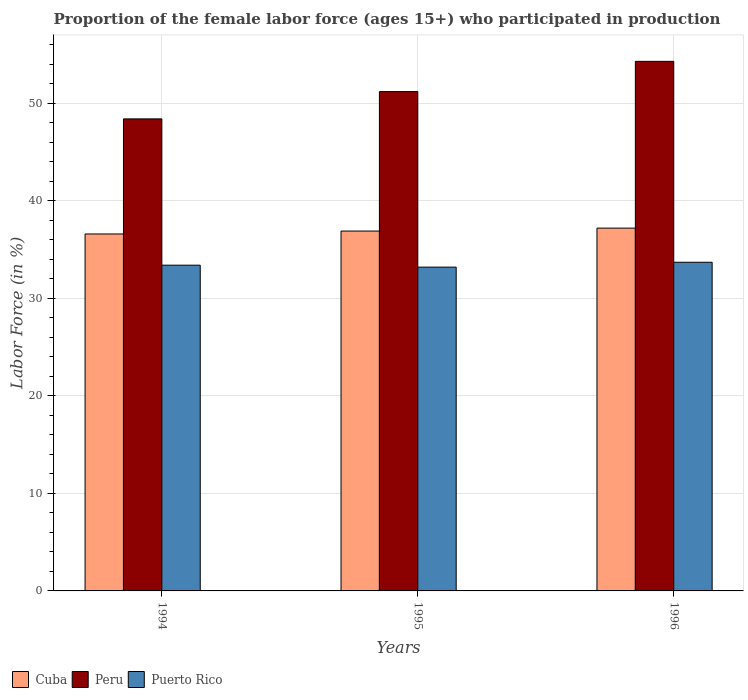How many different coloured bars are there?
Provide a short and direct response. 3. How many groups of bars are there?
Make the answer very short. 3. Are the number of bars per tick equal to the number of legend labels?
Your answer should be very brief. Yes. What is the label of the 1st group of bars from the left?
Keep it short and to the point. 1994. What is the proportion of the female labor force who participated in production in Peru in 1995?
Ensure brevity in your answer.  51.2. Across all years, what is the maximum proportion of the female labor force who participated in production in Puerto Rico?
Your response must be concise. 33.7. Across all years, what is the minimum proportion of the female labor force who participated in production in Peru?
Your answer should be very brief. 48.4. In which year was the proportion of the female labor force who participated in production in Peru minimum?
Provide a succinct answer. 1994. What is the total proportion of the female labor force who participated in production in Puerto Rico in the graph?
Offer a very short reply. 100.3. What is the difference between the proportion of the female labor force who participated in production in Cuba in 1995 and that in 1996?
Provide a short and direct response. -0.3. What is the difference between the proportion of the female labor force who participated in production in Peru in 1994 and the proportion of the female labor force who participated in production in Puerto Rico in 1995?
Ensure brevity in your answer.  15.2. What is the average proportion of the female labor force who participated in production in Puerto Rico per year?
Offer a very short reply. 33.43. In how many years, is the proportion of the female labor force who participated in production in Peru greater than 34 %?
Ensure brevity in your answer.  3. What is the ratio of the proportion of the female labor force who participated in production in Puerto Rico in 1994 to that in 1996?
Give a very brief answer. 0.99. What is the difference between the highest and the second highest proportion of the female labor force who participated in production in Cuba?
Make the answer very short. 0.3. In how many years, is the proportion of the female labor force who participated in production in Cuba greater than the average proportion of the female labor force who participated in production in Cuba taken over all years?
Your response must be concise. 2. Is the sum of the proportion of the female labor force who participated in production in Cuba in 1994 and 1996 greater than the maximum proportion of the female labor force who participated in production in Peru across all years?
Provide a short and direct response. Yes. What does the 1st bar from the right in 1995 represents?
Provide a short and direct response. Puerto Rico. How many bars are there?
Give a very brief answer. 9. How many years are there in the graph?
Offer a very short reply. 3. Does the graph contain any zero values?
Your answer should be compact. No. Does the graph contain grids?
Your answer should be compact. Yes. Where does the legend appear in the graph?
Your response must be concise. Bottom left. How are the legend labels stacked?
Give a very brief answer. Horizontal. What is the title of the graph?
Give a very brief answer. Proportion of the female labor force (ages 15+) who participated in production. What is the label or title of the X-axis?
Your answer should be compact. Years. What is the label or title of the Y-axis?
Ensure brevity in your answer.  Labor Force (in %). What is the Labor Force (in %) in Cuba in 1994?
Provide a succinct answer. 36.6. What is the Labor Force (in %) in Peru in 1994?
Your answer should be very brief. 48.4. What is the Labor Force (in %) of Puerto Rico in 1994?
Offer a terse response. 33.4. What is the Labor Force (in %) of Cuba in 1995?
Your answer should be compact. 36.9. What is the Labor Force (in %) in Peru in 1995?
Give a very brief answer. 51.2. What is the Labor Force (in %) of Puerto Rico in 1995?
Offer a very short reply. 33.2. What is the Labor Force (in %) in Cuba in 1996?
Make the answer very short. 37.2. What is the Labor Force (in %) of Peru in 1996?
Ensure brevity in your answer.  54.3. What is the Labor Force (in %) in Puerto Rico in 1996?
Provide a short and direct response. 33.7. Across all years, what is the maximum Labor Force (in %) of Cuba?
Offer a terse response. 37.2. Across all years, what is the maximum Labor Force (in %) in Peru?
Offer a very short reply. 54.3. Across all years, what is the maximum Labor Force (in %) in Puerto Rico?
Your answer should be very brief. 33.7. Across all years, what is the minimum Labor Force (in %) of Cuba?
Offer a terse response. 36.6. Across all years, what is the minimum Labor Force (in %) of Peru?
Offer a very short reply. 48.4. Across all years, what is the minimum Labor Force (in %) of Puerto Rico?
Your answer should be very brief. 33.2. What is the total Labor Force (in %) in Cuba in the graph?
Your answer should be compact. 110.7. What is the total Labor Force (in %) in Peru in the graph?
Your response must be concise. 153.9. What is the total Labor Force (in %) of Puerto Rico in the graph?
Your response must be concise. 100.3. What is the difference between the Labor Force (in %) of Cuba in 1994 and that in 1995?
Your answer should be compact. -0.3. What is the difference between the Labor Force (in %) in Puerto Rico in 1994 and that in 1995?
Your response must be concise. 0.2. What is the difference between the Labor Force (in %) in Cuba in 1994 and that in 1996?
Provide a short and direct response. -0.6. What is the difference between the Labor Force (in %) in Peru in 1995 and that in 1996?
Ensure brevity in your answer.  -3.1. What is the difference between the Labor Force (in %) of Puerto Rico in 1995 and that in 1996?
Keep it short and to the point. -0.5. What is the difference between the Labor Force (in %) in Cuba in 1994 and the Labor Force (in %) in Peru in 1995?
Your answer should be very brief. -14.6. What is the difference between the Labor Force (in %) in Cuba in 1994 and the Labor Force (in %) in Peru in 1996?
Your answer should be very brief. -17.7. What is the difference between the Labor Force (in %) in Cuba in 1994 and the Labor Force (in %) in Puerto Rico in 1996?
Your answer should be compact. 2.9. What is the difference between the Labor Force (in %) of Cuba in 1995 and the Labor Force (in %) of Peru in 1996?
Offer a very short reply. -17.4. What is the average Labor Force (in %) of Cuba per year?
Ensure brevity in your answer.  36.9. What is the average Labor Force (in %) of Peru per year?
Give a very brief answer. 51.3. What is the average Labor Force (in %) in Puerto Rico per year?
Keep it short and to the point. 33.43. In the year 1994, what is the difference between the Labor Force (in %) in Cuba and Labor Force (in %) in Peru?
Offer a terse response. -11.8. In the year 1994, what is the difference between the Labor Force (in %) in Cuba and Labor Force (in %) in Puerto Rico?
Keep it short and to the point. 3.2. In the year 1995, what is the difference between the Labor Force (in %) of Cuba and Labor Force (in %) of Peru?
Offer a terse response. -14.3. In the year 1995, what is the difference between the Labor Force (in %) of Cuba and Labor Force (in %) of Puerto Rico?
Provide a succinct answer. 3.7. In the year 1995, what is the difference between the Labor Force (in %) of Peru and Labor Force (in %) of Puerto Rico?
Provide a succinct answer. 18. In the year 1996, what is the difference between the Labor Force (in %) of Cuba and Labor Force (in %) of Peru?
Offer a terse response. -17.1. In the year 1996, what is the difference between the Labor Force (in %) in Peru and Labor Force (in %) in Puerto Rico?
Keep it short and to the point. 20.6. What is the ratio of the Labor Force (in %) of Cuba in 1994 to that in 1995?
Offer a terse response. 0.99. What is the ratio of the Labor Force (in %) in Peru in 1994 to that in 1995?
Make the answer very short. 0.95. What is the ratio of the Labor Force (in %) in Puerto Rico in 1994 to that in 1995?
Offer a very short reply. 1.01. What is the ratio of the Labor Force (in %) in Cuba in 1994 to that in 1996?
Give a very brief answer. 0.98. What is the ratio of the Labor Force (in %) of Peru in 1994 to that in 1996?
Offer a terse response. 0.89. What is the ratio of the Labor Force (in %) in Puerto Rico in 1994 to that in 1996?
Keep it short and to the point. 0.99. What is the ratio of the Labor Force (in %) in Cuba in 1995 to that in 1996?
Offer a terse response. 0.99. What is the ratio of the Labor Force (in %) of Peru in 1995 to that in 1996?
Make the answer very short. 0.94. What is the ratio of the Labor Force (in %) in Puerto Rico in 1995 to that in 1996?
Your answer should be very brief. 0.99. What is the difference between the highest and the second highest Labor Force (in %) in Cuba?
Provide a succinct answer. 0.3. What is the difference between the highest and the second highest Labor Force (in %) of Peru?
Provide a succinct answer. 3.1. What is the difference between the highest and the second highest Labor Force (in %) of Puerto Rico?
Offer a terse response. 0.3. What is the difference between the highest and the lowest Labor Force (in %) in Peru?
Your answer should be compact. 5.9. What is the difference between the highest and the lowest Labor Force (in %) in Puerto Rico?
Provide a short and direct response. 0.5. 